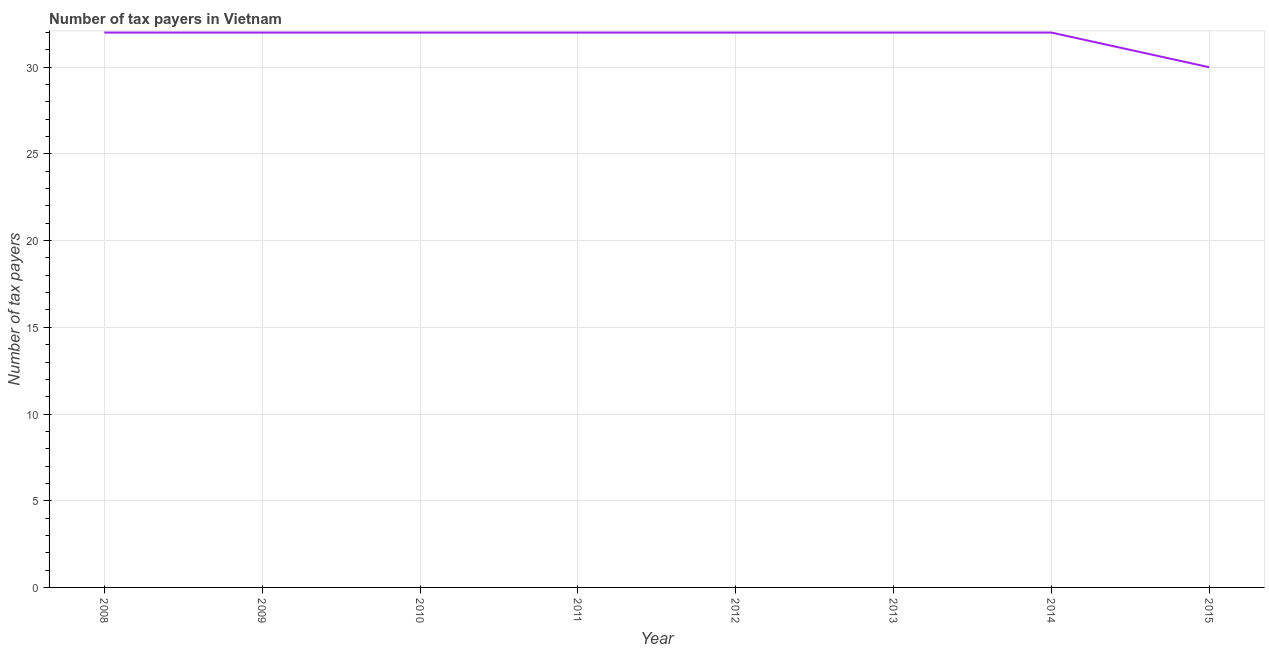What is the number of tax payers in 2014?
Offer a terse response. 32. Across all years, what is the maximum number of tax payers?
Make the answer very short. 32. Across all years, what is the minimum number of tax payers?
Your answer should be compact. 30. In which year was the number of tax payers maximum?
Provide a short and direct response. 2008. In which year was the number of tax payers minimum?
Provide a succinct answer. 2015. What is the sum of the number of tax payers?
Your answer should be compact. 254. What is the difference between the number of tax payers in 2008 and 2013?
Give a very brief answer. 0. What is the average number of tax payers per year?
Your answer should be very brief. 31.75. In how many years, is the number of tax payers greater than 7 ?
Ensure brevity in your answer.  8. Do a majority of the years between 2015 and 2012 (inclusive) have number of tax payers greater than 3 ?
Provide a short and direct response. Yes. Is the number of tax payers in 2008 less than that in 2011?
Your answer should be compact. No. What is the difference between the highest and the second highest number of tax payers?
Make the answer very short. 0. What is the difference between the highest and the lowest number of tax payers?
Give a very brief answer. 2. In how many years, is the number of tax payers greater than the average number of tax payers taken over all years?
Ensure brevity in your answer.  7. Are the values on the major ticks of Y-axis written in scientific E-notation?
Provide a short and direct response. No. What is the title of the graph?
Make the answer very short. Number of tax payers in Vietnam. What is the label or title of the X-axis?
Provide a short and direct response. Year. What is the label or title of the Y-axis?
Your response must be concise. Number of tax payers. What is the Number of tax payers in 2009?
Your answer should be compact. 32. What is the Number of tax payers of 2010?
Keep it short and to the point. 32. What is the Number of tax payers of 2011?
Your answer should be compact. 32. What is the Number of tax payers in 2015?
Give a very brief answer. 30. What is the difference between the Number of tax payers in 2008 and 2009?
Ensure brevity in your answer.  0. What is the difference between the Number of tax payers in 2008 and 2010?
Offer a very short reply. 0. What is the difference between the Number of tax payers in 2008 and 2011?
Your response must be concise. 0. What is the difference between the Number of tax payers in 2008 and 2013?
Offer a very short reply. 0. What is the difference between the Number of tax payers in 2008 and 2015?
Your response must be concise. 2. What is the difference between the Number of tax payers in 2009 and 2015?
Your response must be concise. 2. What is the difference between the Number of tax payers in 2011 and 2013?
Ensure brevity in your answer.  0. What is the difference between the Number of tax payers in 2011 and 2014?
Provide a short and direct response. 0. What is the difference between the Number of tax payers in 2011 and 2015?
Your response must be concise. 2. What is the difference between the Number of tax payers in 2012 and 2014?
Your response must be concise. 0. What is the difference between the Number of tax payers in 2012 and 2015?
Keep it short and to the point. 2. What is the difference between the Number of tax payers in 2013 and 2015?
Ensure brevity in your answer.  2. What is the difference between the Number of tax payers in 2014 and 2015?
Give a very brief answer. 2. What is the ratio of the Number of tax payers in 2008 to that in 2015?
Offer a terse response. 1.07. What is the ratio of the Number of tax payers in 2009 to that in 2013?
Provide a short and direct response. 1. What is the ratio of the Number of tax payers in 2009 to that in 2015?
Provide a short and direct response. 1.07. What is the ratio of the Number of tax payers in 2010 to that in 2013?
Provide a succinct answer. 1. What is the ratio of the Number of tax payers in 2010 to that in 2014?
Keep it short and to the point. 1. What is the ratio of the Number of tax payers in 2010 to that in 2015?
Your response must be concise. 1.07. What is the ratio of the Number of tax payers in 2011 to that in 2012?
Your answer should be very brief. 1. What is the ratio of the Number of tax payers in 2011 to that in 2015?
Ensure brevity in your answer.  1.07. What is the ratio of the Number of tax payers in 2012 to that in 2015?
Make the answer very short. 1.07. What is the ratio of the Number of tax payers in 2013 to that in 2014?
Make the answer very short. 1. What is the ratio of the Number of tax payers in 2013 to that in 2015?
Provide a succinct answer. 1.07. What is the ratio of the Number of tax payers in 2014 to that in 2015?
Your answer should be very brief. 1.07. 